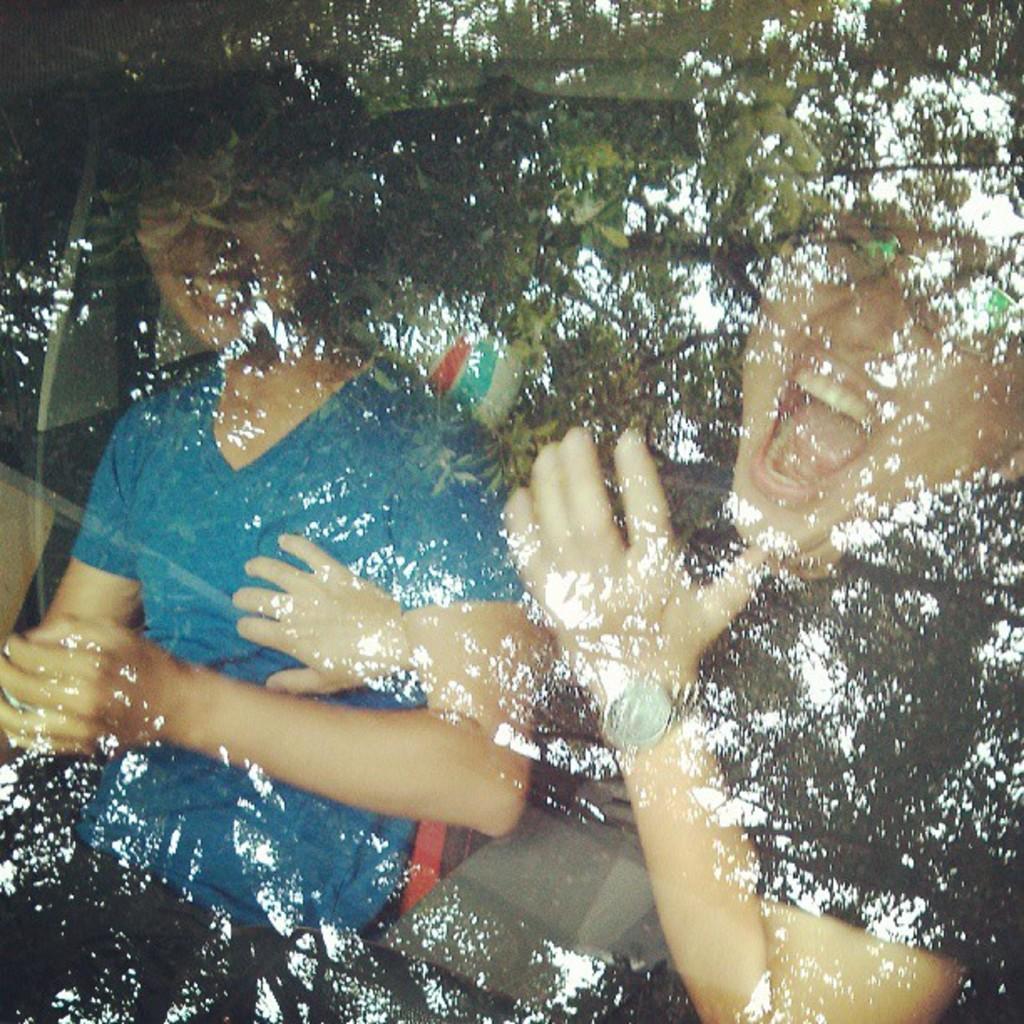Describe this image in one or two sentences. In this picture I can see two people are sitting and smiling. This person is blue color t-shirt. I can also see tree a tree. 